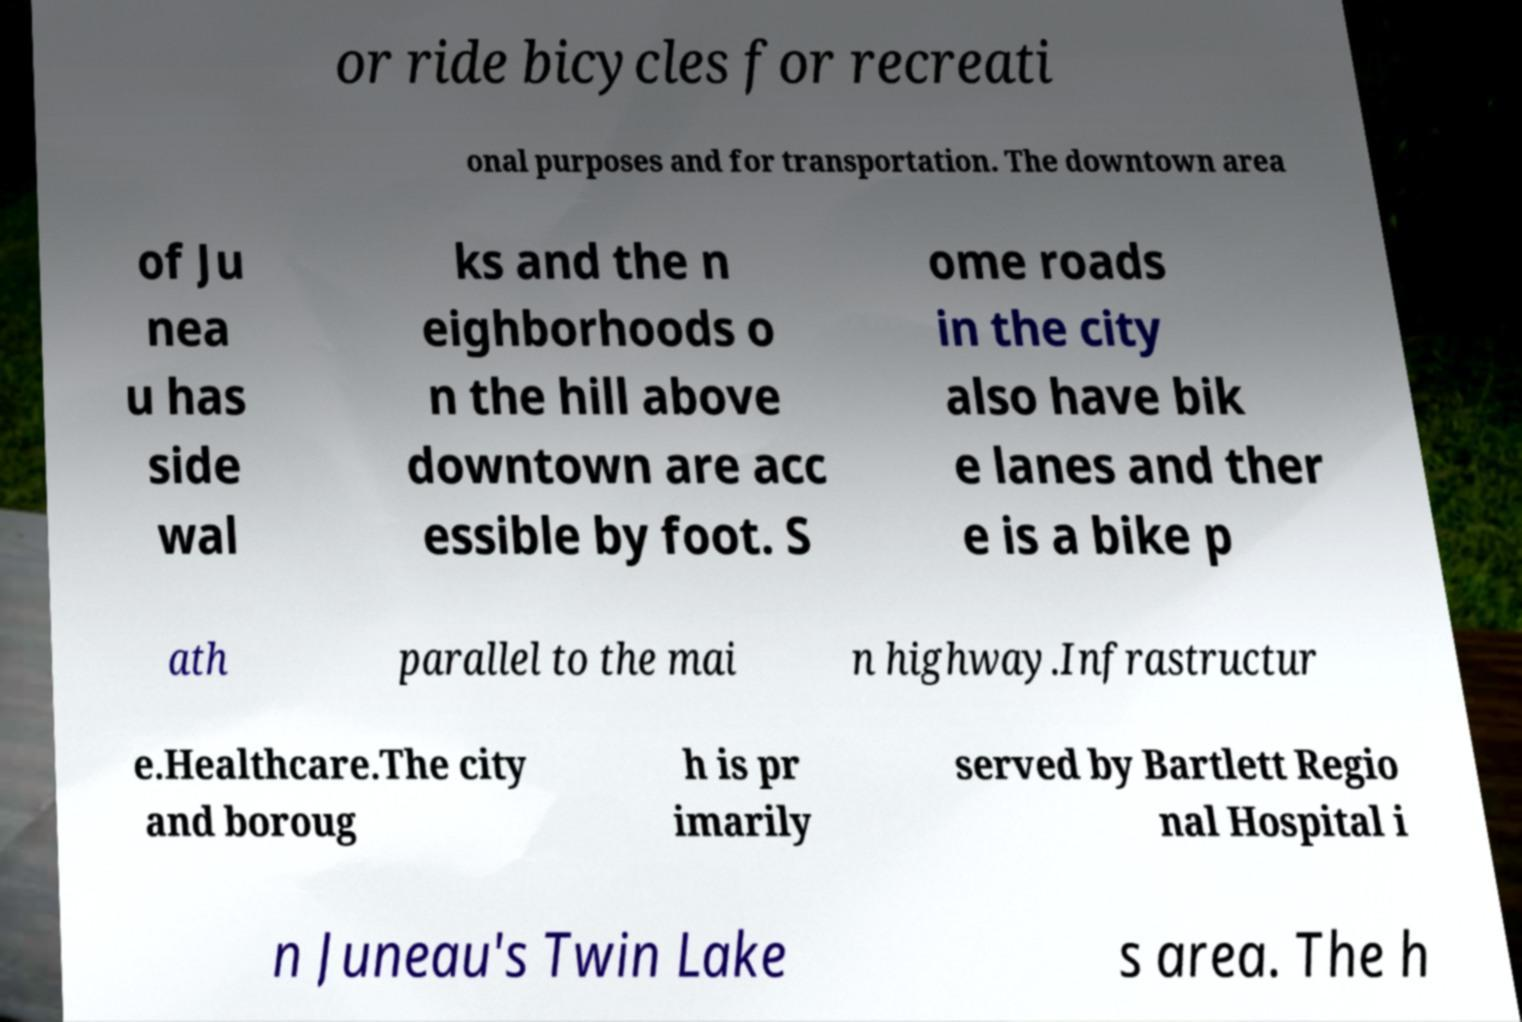Could you extract and type out the text from this image? or ride bicycles for recreati onal purposes and for transportation. The downtown area of Ju nea u has side wal ks and the n eighborhoods o n the hill above downtown are acc essible by foot. S ome roads in the city also have bik e lanes and ther e is a bike p ath parallel to the mai n highway.Infrastructur e.Healthcare.The city and boroug h is pr imarily served by Bartlett Regio nal Hospital i n Juneau's Twin Lake s area. The h 